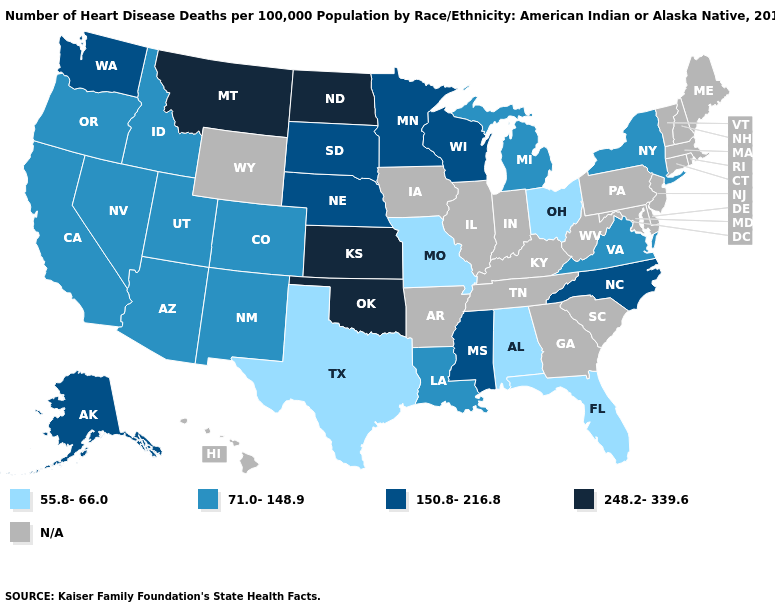How many symbols are there in the legend?
Quick response, please. 5. What is the value of Washington?
Keep it brief. 150.8-216.8. What is the highest value in the USA?
Write a very short answer. 248.2-339.6. What is the value of Florida?
Concise answer only. 55.8-66.0. What is the lowest value in the MidWest?
Answer briefly. 55.8-66.0. What is the value of Idaho?
Be succinct. 71.0-148.9. Does Alabama have the highest value in the South?
Write a very short answer. No. Does the first symbol in the legend represent the smallest category?
Give a very brief answer. Yes. Does Texas have the lowest value in the USA?
Keep it brief. Yes. Which states hav the highest value in the Northeast?
Give a very brief answer. New York. What is the value of South Dakota?
Concise answer only. 150.8-216.8. Does the map have missing data?
Give a very brief answer. Yes. Name the states that have a value in the range 71.0-148.9?
Short answer required. Arizona, California, Colorado, Idaho, Louisiana, Michigan, Nevada, New Mexico, New York, Oregon, Utah, Virginia. Among the states that border Connecticut , which have the lowest value?
Write a very short answer. New York. Which states have the lowest value in the USA?
Be succinct. Alabama, Florida, Missouri, Ohio, Texas. 